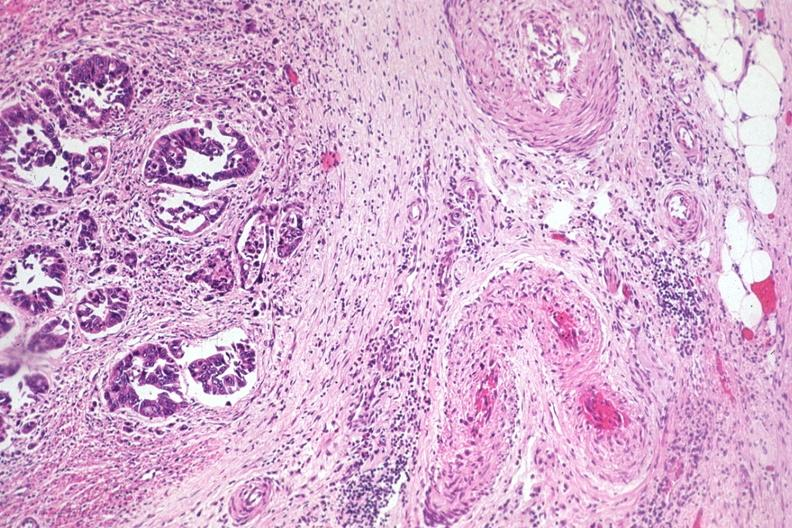s gastrointestinal present?
Answer the question using a single word or phrase. Yes 